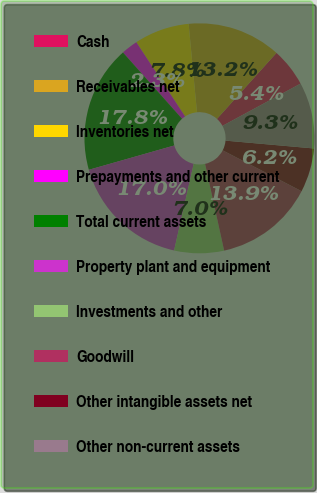Convert chart. <chart><loc_0><loc_0><loc_500><loc_500><pie_chart><fcel>Cash<fcel>Receivables net<fcel>Inventories net<fcel>Prepayments and other current<fcel>Total current assets<fcel>Property plant and equipment<fcel>Investments and other<fcel>Goodwill<fcel>Other intangible assets net<fcel>Other non-current assets<nl><fcel>5.43%<fcel>13.18%<fcel>7.75%<fcel>2.33%<fcel>17.83%<fcel>17.05%<fcel>6.98%<fcel>13.95%<fcel>6.2%<fcel>9.3%<nl></chart> 